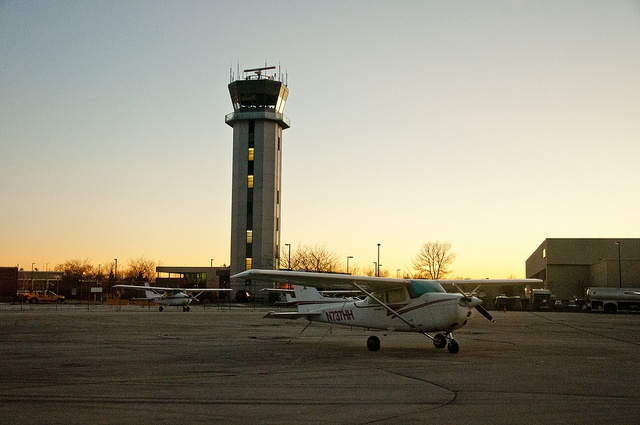Describe the objects in this image and their specific colors. I can see airplane in gray and black tones, truck in gray and black tones, airplane in gray and black tones, truck in gray, black, maroon, and brown tones, and truck in gray and black tones in this image. 